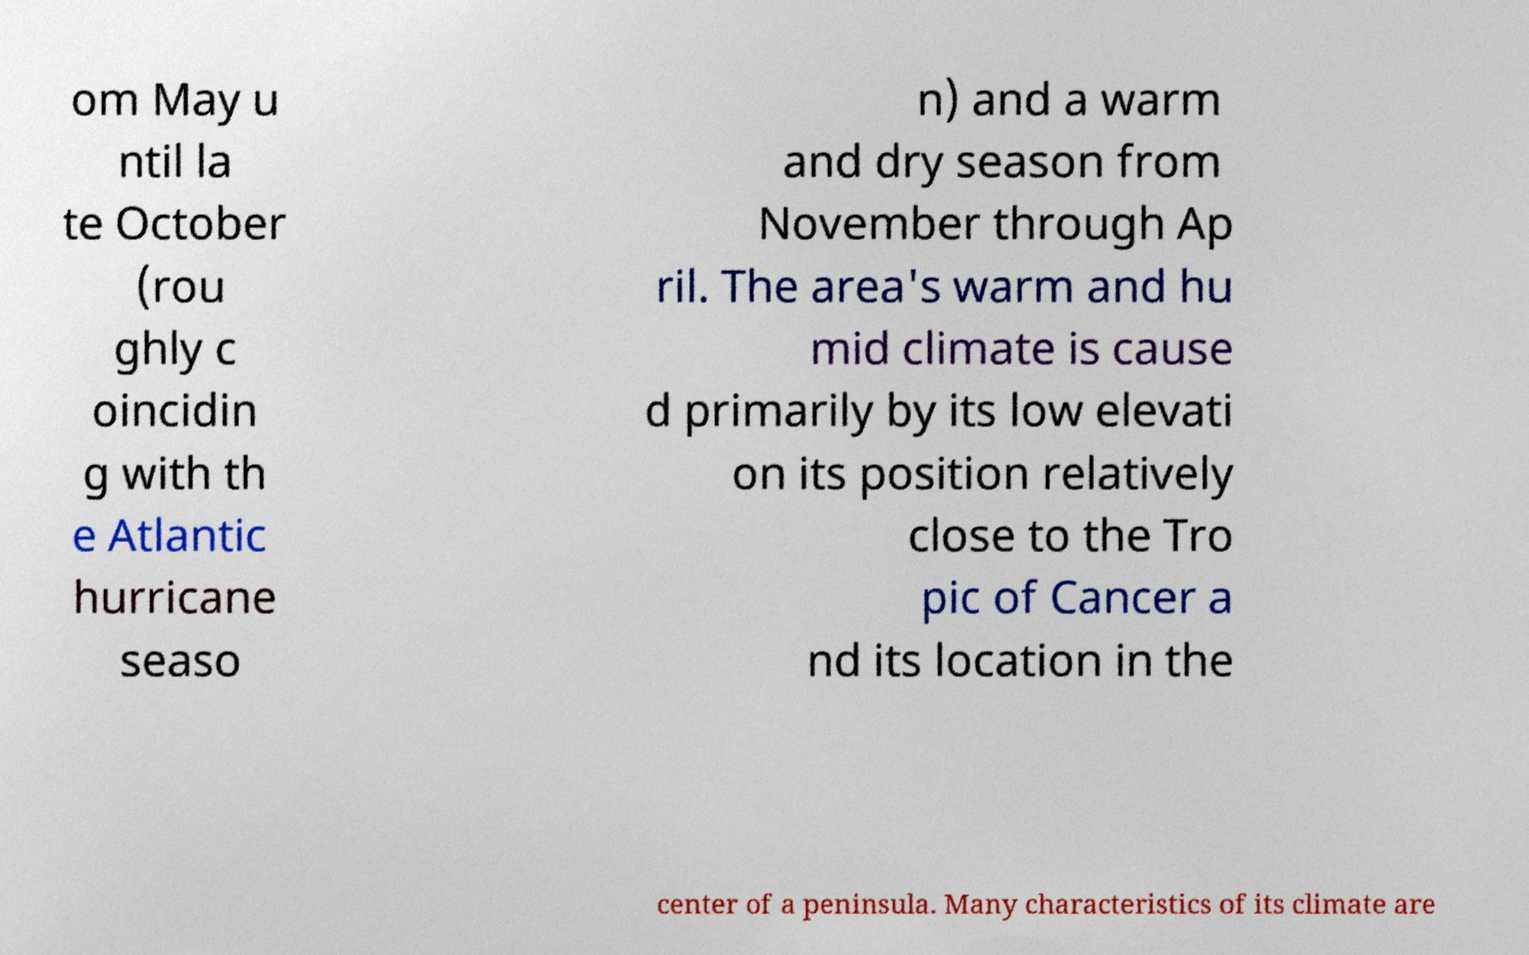Can you read and provide the text displayed in the image?This photo seems to have some interesting text. Can you extract and type it out for me? om May u ntil la te October (rou ghly c oincidin g with th e Atlantic hurricane seaso n) and a warm and dry season from November through Ap ril. The area's warm and hu mid climate is cause d primarily by its low elevati on its position relatively close to the Tro pic of Cancer a nd its location in the center of a peninsula. Many characteristics of its climate are 